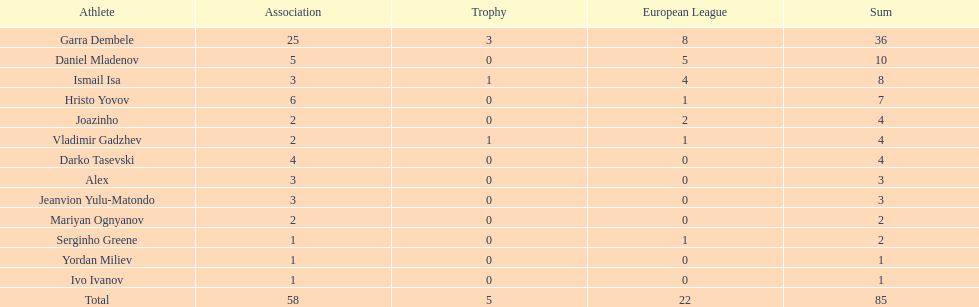Who had the most goal scores? Garra Dembele. 